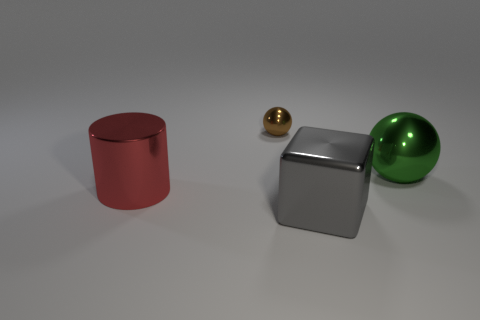The brown thing that is the same material as the large cylinder is what size?
Your answer should be very brief. Small. There is a big shiny thing on the left side of the ball left of the green ball; are there any tiny shiny objects that are to the right of it?
Offer a very short reply. Yes. Is the size of the shiny thing in front of the red cylinder the same as the green thing?
Your answer should be compact. Yes. How many brown shiny objects are the same size as the red object?
Your answer should be compact. 0. The tiny brown metallic thing is what shape?
Your answer should be very brief. Sphere. Are there more shiny objects to the right of the gray cube than matte objects?
Your answer should be compact. Yes. Do the big red thing and the large metal thing that is behind the big red metallic object have the same shape?
Your answer should be very brief. No. Are there any big purple matte spheres?
Give a very brief answer. No. How many large objects are green rubber spheres or metal things?
Offer a terse response. 3. Is the number of big green metal objects on the right side of the block greater than the number of tiny things in front of the big green thing?
Ensure brevity in your answer.  Yes. 